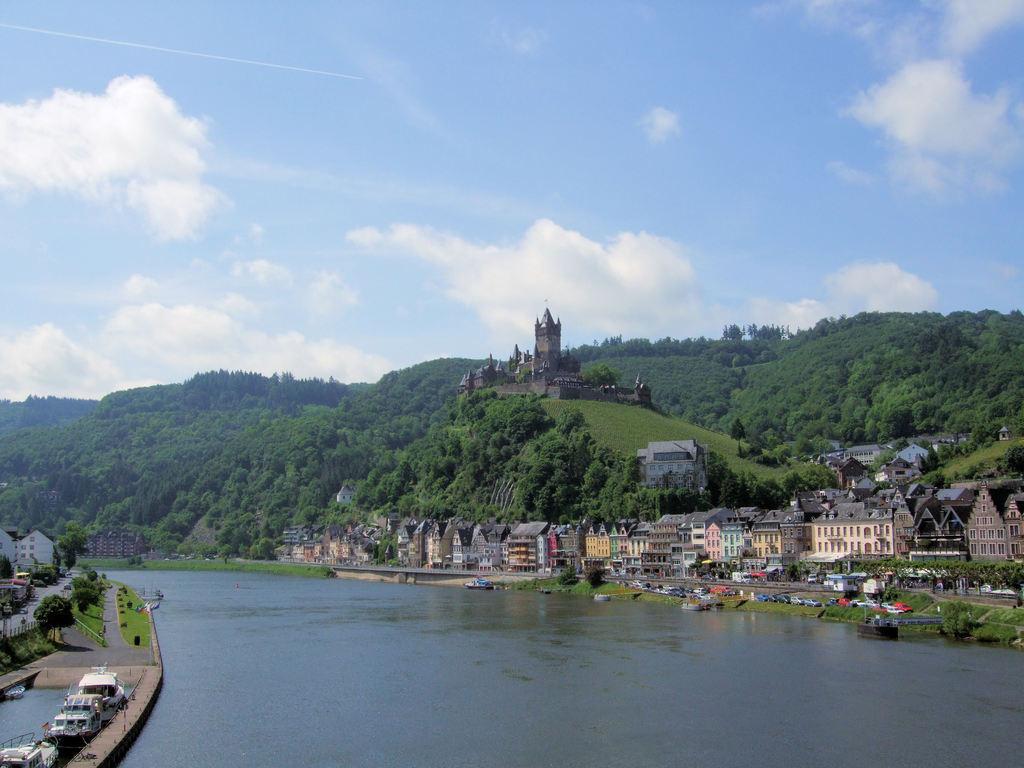Describe this image in one or two sentences. There are buildings and trees, this is water and a sky, these are boats. 